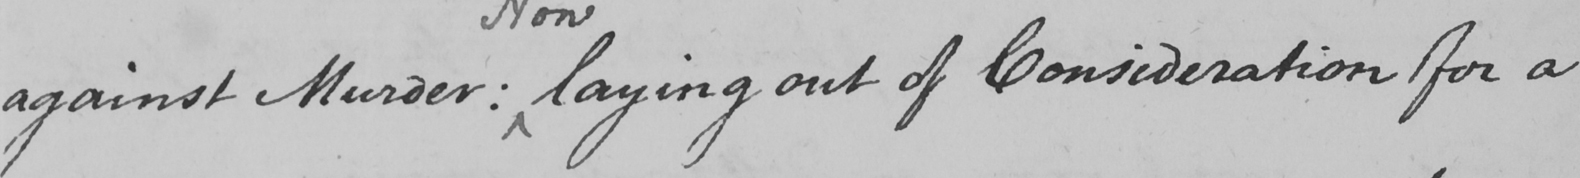Please transcribe the handwritten text in this image. against Murder :  laying out of Consideration for a 